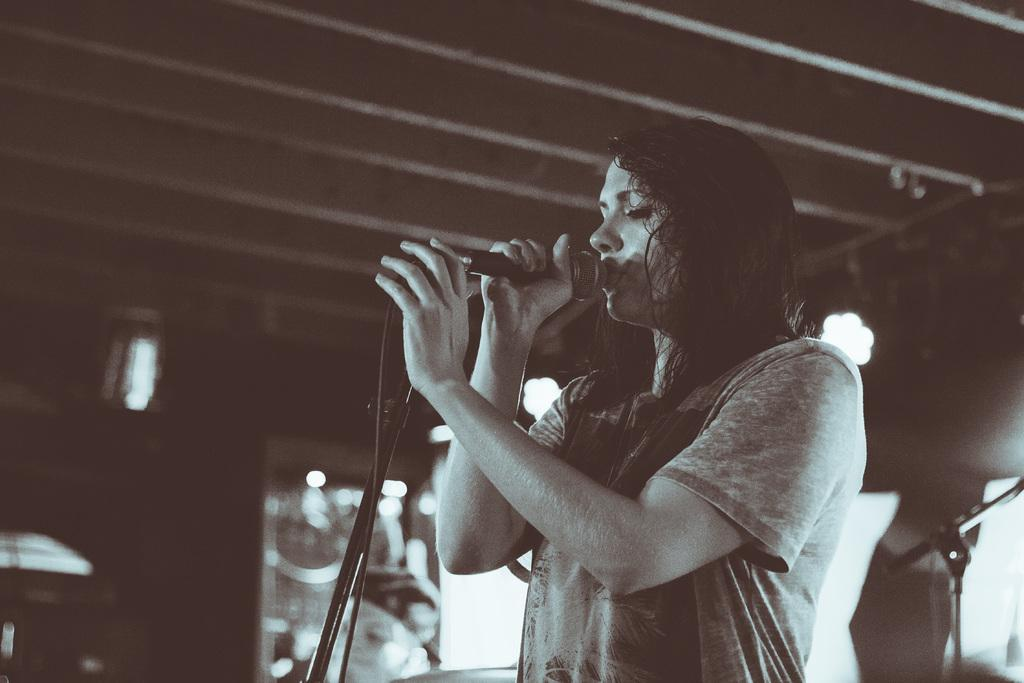Who is the main subject in the foreground of the image? There is a woman in the foreground of the image. What is the woman holding in her hands? The woman is holding a microphone in her hands. What is the woman doing with the microphone? The woman is singing. What can be seen in the background of the image? There is a ceiling and lights visible in the background of the image. What type of leaf is being used as a prop in the image? There is no leaf present in the image; the woman is holding a microphone and singing. 